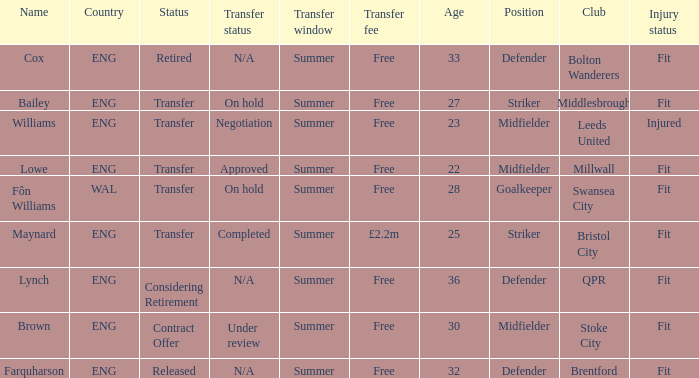What is the name of the free transfer fee with a transfer status and an ENG country? Bailey, Williams, Lowe. 